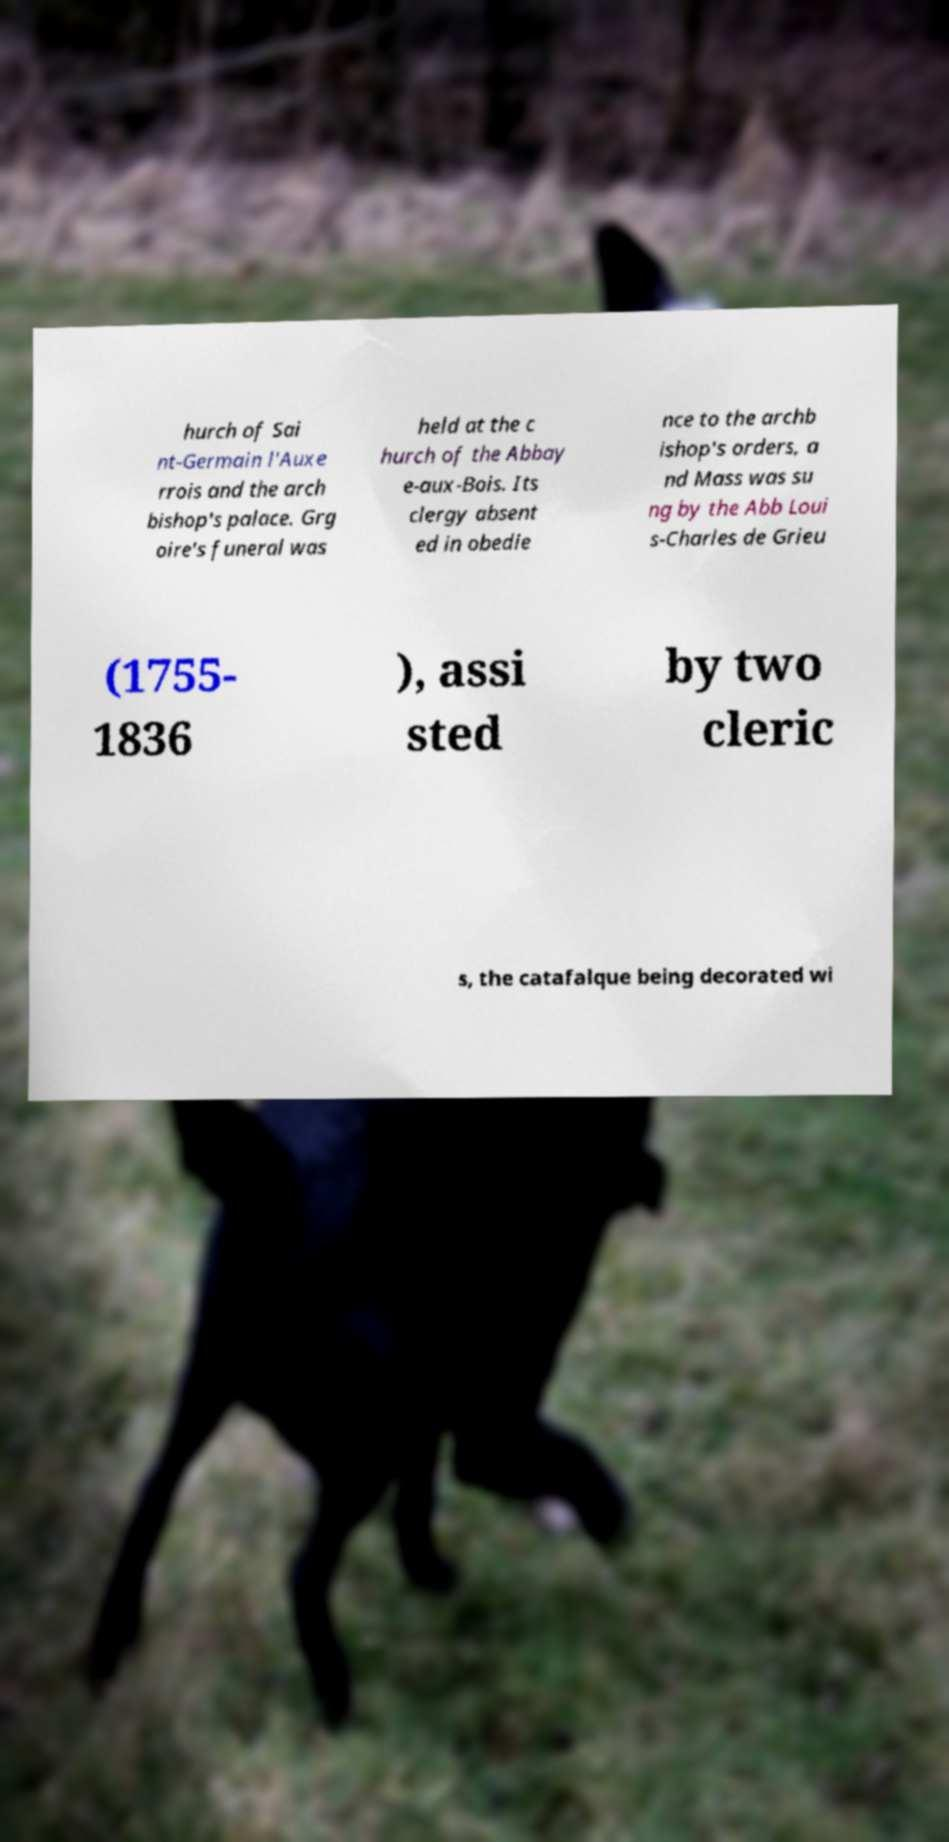I need the written content from this picture converted into text. Can you do that? hurch of Sai nt-Germain l'Auxe rrois and the arch bishop's palace. Grg oire's funeral was held at the c hurch of the Abbay e-aux-Bois. Its clergy absent ed in obedie nce to the archb ishop's orders, a nd Mass was su ng by the Abb Loui s-Charles de Grieu (1755- 1836 ), assi sted by two cleric s, the catafalque being decorated wi 